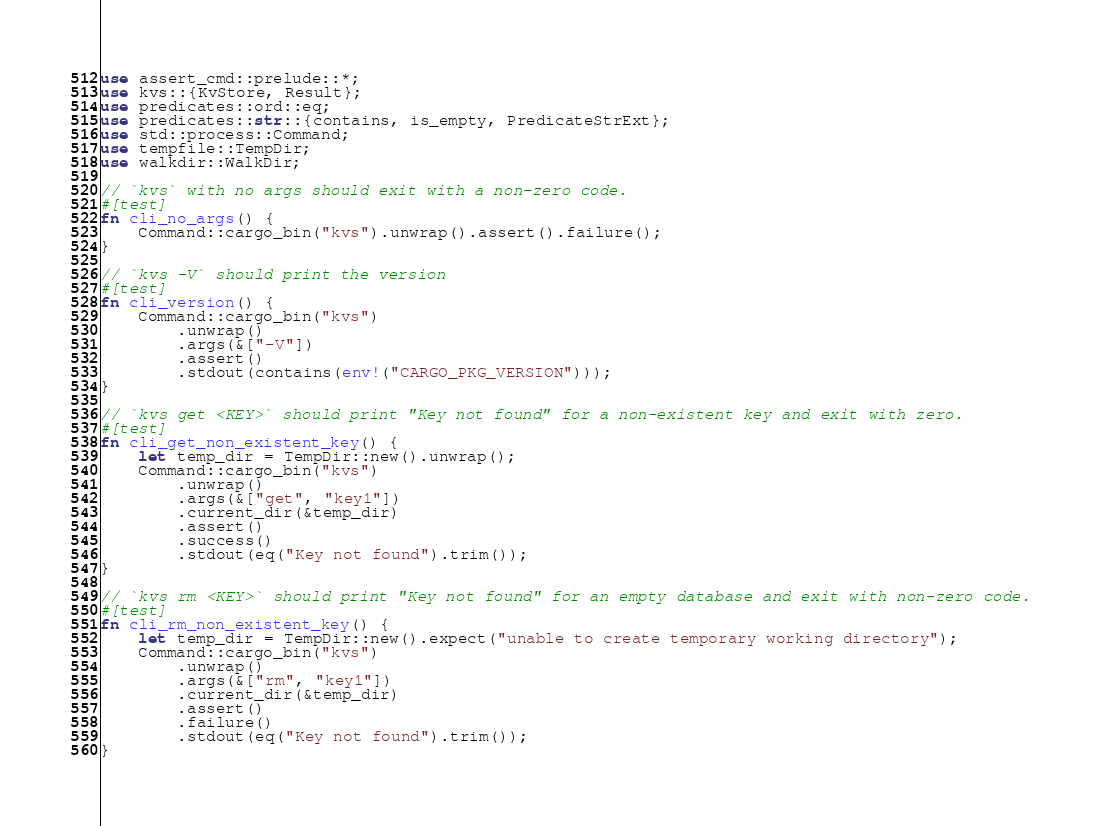<code> <loc_0><loc_0><loc_500><loc_500><_Rust_>use assert_cmd::prelude::*;
use kvs::{KvStore, Result};
use predicates::ord::eq;
use predicates::str::{contains, is_empty, PredicateStrExt};
use std::process::Command;
use tempfile::TempDir;
use walkdir::WalkDir;

// `kvs` with no args should exit with a non-zero code.
#[test]
fn cli_no_args() {
    Command::cargo_bin("kvs").unwrap().assert().failure();
}

// `kvs -V` should print the version
#[test]
fn cli_version() {
    Command::cargo_bin("kvs")
        .unwrap()
        .args(&["-V"])
        .assert()
        .stdout(contains(env!("CARGO_PKG_VERSION")));
}

// `kvs get <KEY>` should print "Key not found" for a non-existent key and exit with zero.
#[test]
fn cli_get_non_existent_key() {
    let temp_dir = TempDir::new().unwrap();
    Command::cargo_bin("kvs")
        .unwrap()
        .args(&["get", "key1"])
        .current_dir(&temp_dir)
        .assert()
        .success()
        .stdout(eq("Key not found").trim());
}

// `kvs rm <KEY>` should print "Key not found" for an empty database and exit with non-zero code.
#[test]
fn cli_rm_non_existent_key() {
    let temp_dir = TempDir::new().expect("unable to create temporary working directory");
    Command::cargo_bin("kvs")
        .unwrap()
        .args(&["rm", "key1"])
        .current_dir(&temp_dir)
        .assert()
        .failure()
        .stdout(eq("Key not found").trim());
}
</code> 